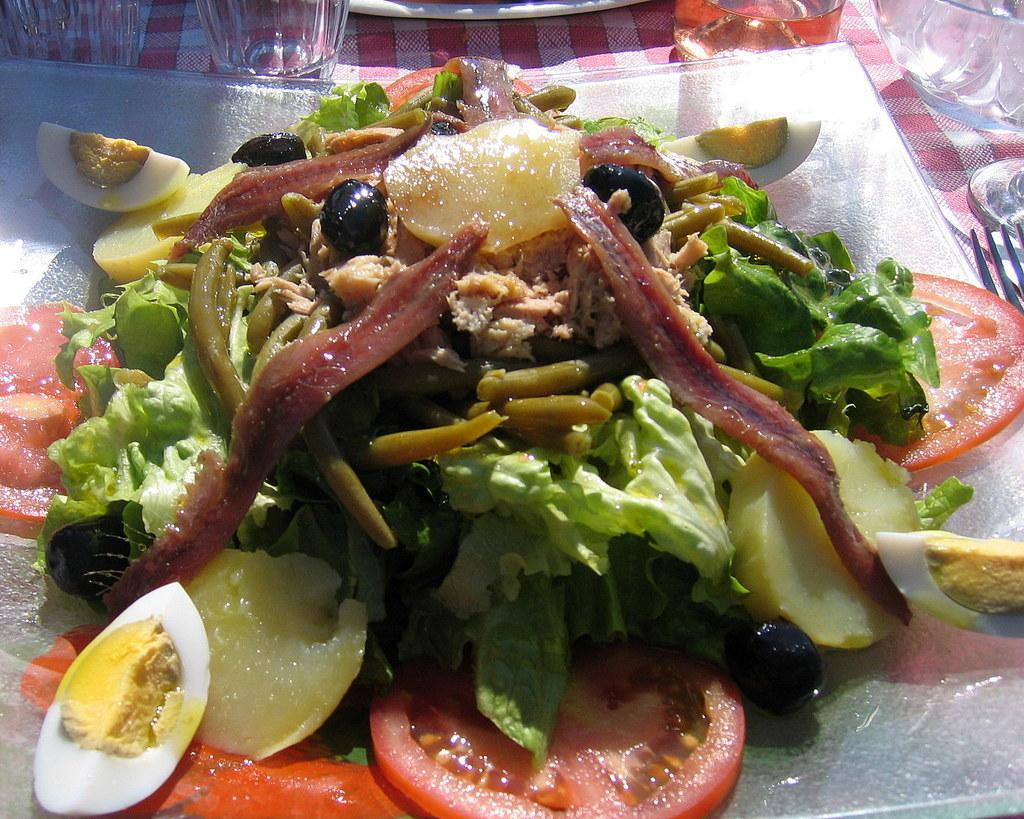How would you summarize this image in a sentence or two? In this image we can see some food items on the plate. And there are glasses, bowl and few objects on the cloth. 